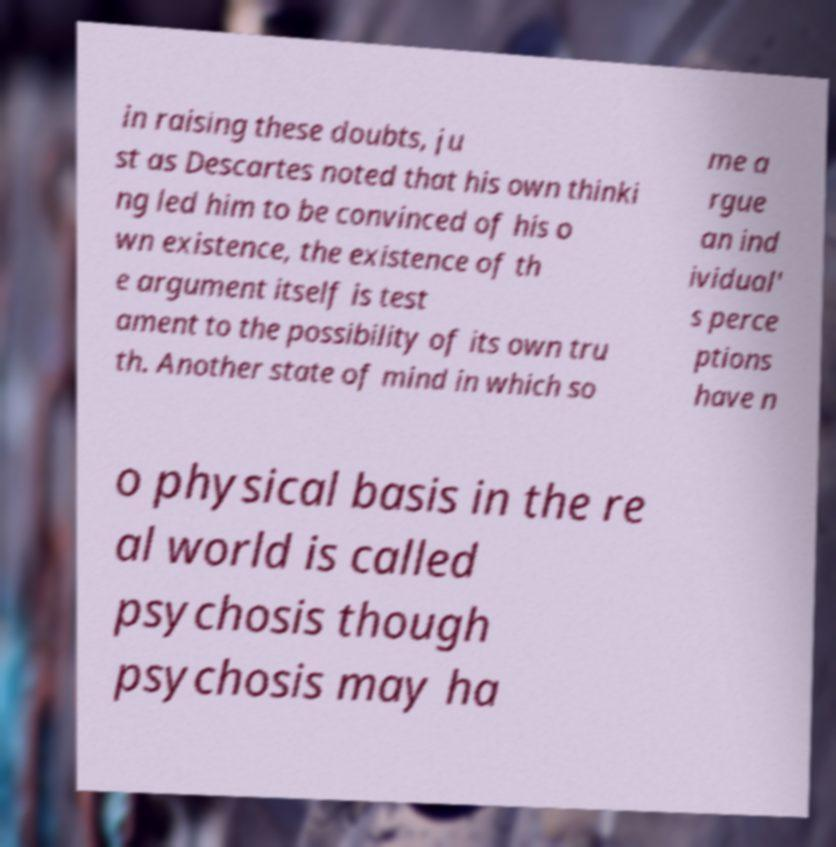Can you read and provide the text displayed in the image?This photo seems to have some interesting text. Can you extract and type it out for me? in raising these doubts, ju st as Descartes noted that his own thinki ng led him to be convinced of his o wn existence, the existence of th e argument itself is test ament to the possibility of its own tru th. Another state of mind in which so me a rgue an ind ividual' s perce ptions have n o physical basis in the re al world is called psychosis though psychosis may ha 